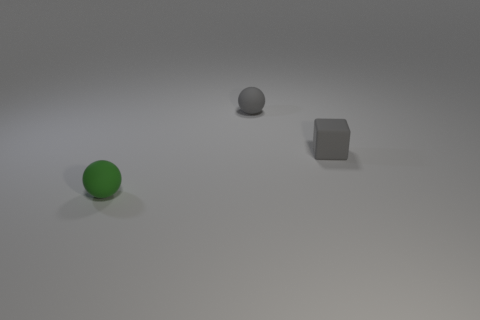There is a tiny thing that is the same color as the tiny matte block; what is its shape?
Your response must be concise. Sphere. Are there any gray cubes that have the same material as the green thing?
Ensure brevity in your answer.  Yes. The thing that is the same color as the rubber block is what size?
Keep it short and to the point. Small. There is a rubber sphere behind the tiny gray thing in front of the small gray rubber sphere; what is its color?
Provide a short and direct response. Gray. Do the cube and the green ball have the same size?
Your answer should be compact. Yes. How many spheres are either green rubber things or small matte objects?
Provide a short and direct response. 2. There is a small rubber object on the right side of the small gray matte sphere; what number of tiny things are behind it?
Keep it short and to the point. 1. What size is the gray rubber thing that is the same shape as the green matte object?
Your response must be concise. Small. There is a small thing that is on the right side of the thing behind the small gray rubber cube; what is its shape?
Offer a terse response. Cube. What size is the matte cube?
Give a very brief answer. Small. 